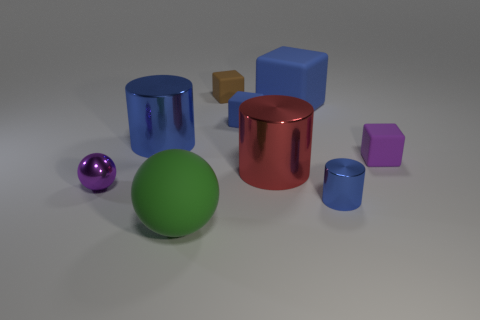Are there more big yellow rubber cylinders than metallic cylinders?
Provide a succinct answer. No. There is a tiny metal object that is right of the brown block; does it have the same color as the big metal cylinder that is to the left of the large red cylinder?
Your answer should be compact. Yes. Is there a purple metal thing in front of the purple thing on the right side of the tiny blue shiny cylinder?
Provide a succinct answer. Yes. Is the number of purple blocks behind the purple block less than the number of large red metal things left of the big blue block?
Provide a succinct answer. Yes. Are the big cylinder that is on the left side of the big green thing and the purple object that is to the right of the large blue metallic cylinder made of the same material?
Provide a short and direct response. No. What number of large things are either red cylinders or yellow cylinders?
Ensure brevity in your answer.  1. The tiny purple thing that is the same material as the brown thing is what shape?
Provide a succinct answer. Cube. Is the number of green objects behind the green sphere less than the number of large brown cylinders?
Provide a short and direct response. No. Is the shape of the small blue matte object the same as the purple rubber object?
Provide a succinct answer. Yes. What number of metallic things are green spheres or large blue cylinders?
Your response must be concise. 1. 